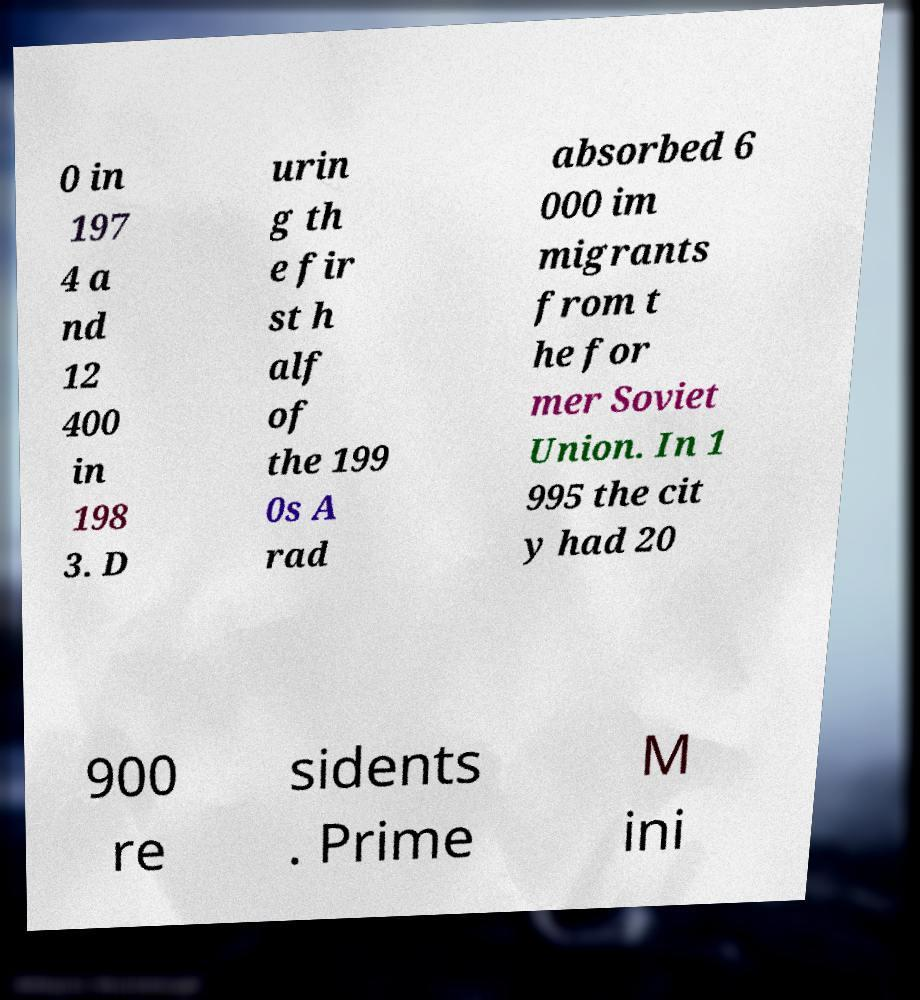There's text embedded in this image that I need extracted. Can you transcribe it verbatim? 0 in 197 4 a nd 12 400 in 198 3. D urin g th e fir st h alf of the 199 0s A rad absorbed 6 000 im migrants from t he for mer Soviet Union. In 1 995 the cit y had 20 900 re sidents . Prime M ini 